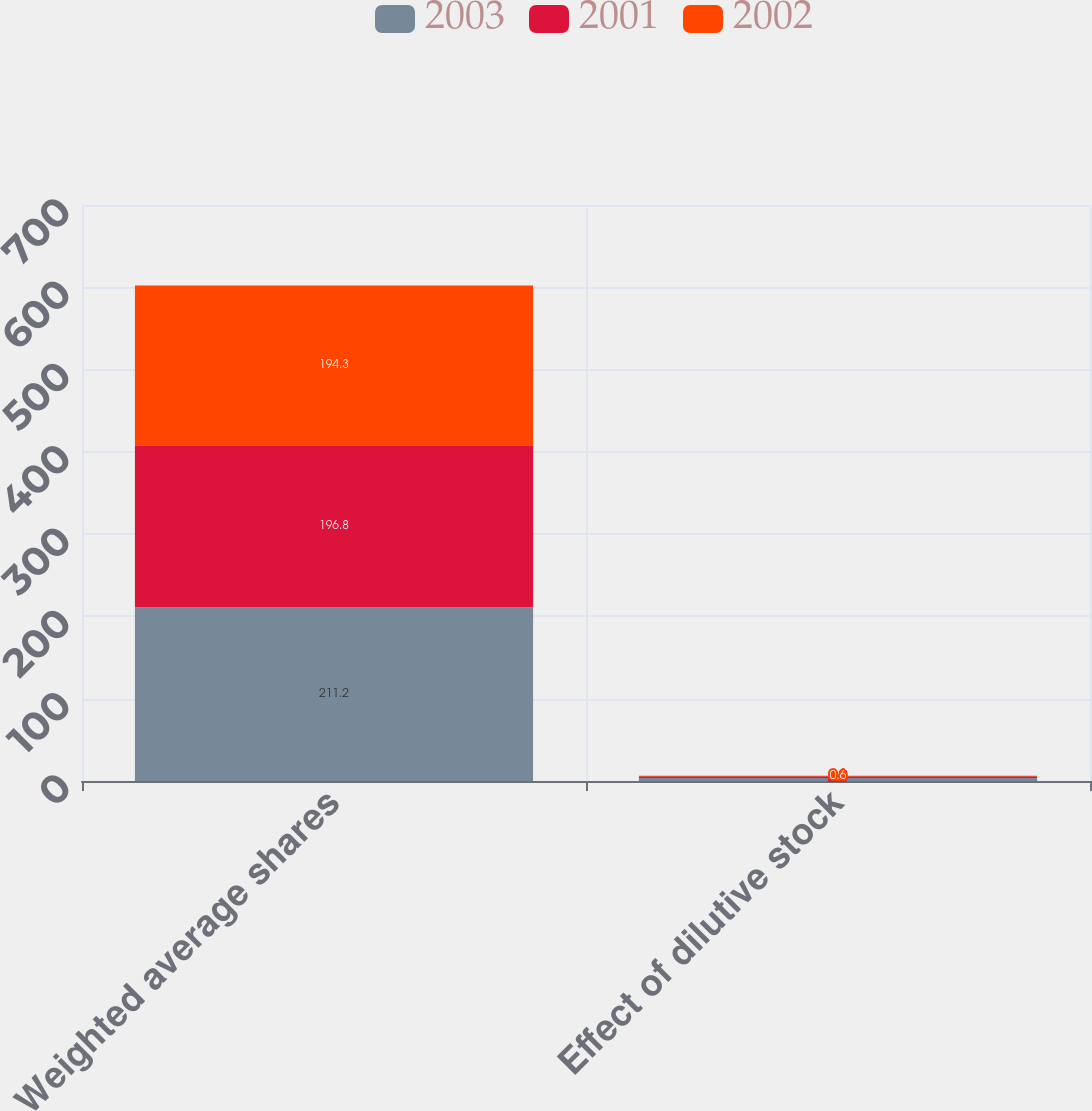Convert chart to OTSL. <chart><loc_0><loc_0><loc_500><loc_500><stacked_bar_chart><ecel><fcel>Weighted average shares<fcel>Effect of dilutive stock<nl><fcel>2003<fcel>211.2<fcel>3.5<nl><fcel>2001<fcel>196.8<fcel>2.3<nl><fcel>2002<fcel>194.3<fcel>0.6<nl></chart> 